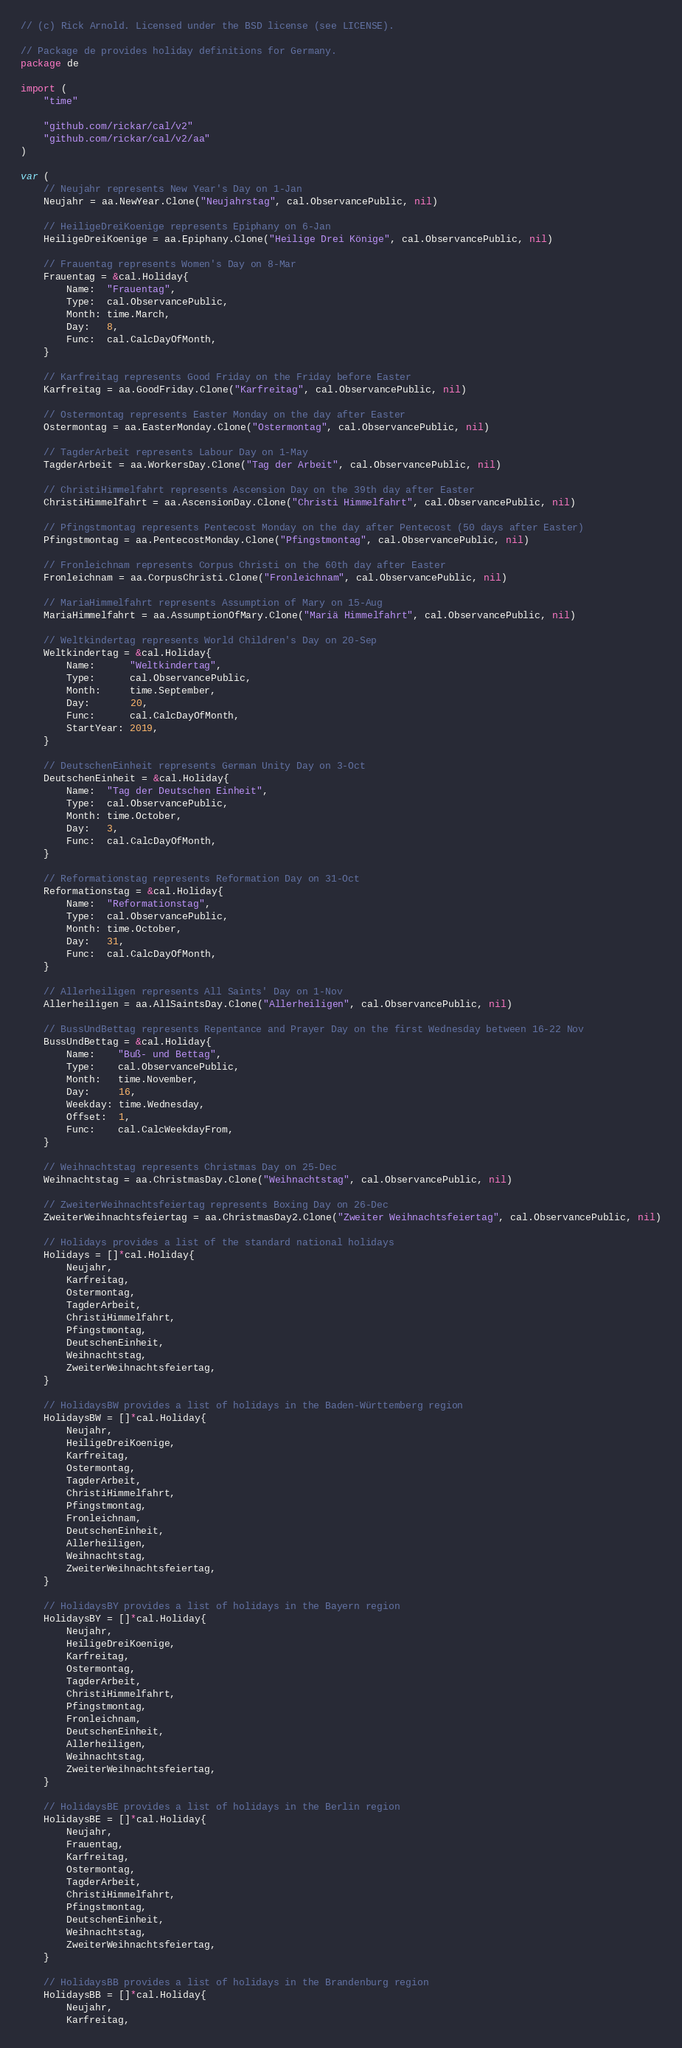<code> <loc_0><loc_0><loc_500><loc_500><_Go_>// (c) Rick Arnold. Licensed under the BSD license (see LICENSE).

// Package de provides holiday definitions for Germany.
package de

import (
	"time"

	"github.com/rickar/cal/v2"
	"github.com/rickar/cal/v2/aa"
)

var (
	// Neujahr represents New Year's Day on 1-Jan
	Neujahr = aa.NewYear.Clone("Neujahrstag", cal.ObservancePublic, nil)

	// HeiligeDreiKoenige represents Epiphany on 6-Jan
	HeiligeDreiKoenige = aa.Epiphany.Clone("Heilige Drei Könige", cal.ObservancePublic, nil)

	// Frauentag represents Women's Day on 8-Mar
	Frauentag = &cal.Holiday{
		Name:  "Frauentag",
		Type:  cal.ObservancePublic,
		Month: time.March,
		Day:   8,
		Func:  cal.CalcDayOfMonth,
	}

	// Karfreitag represents Good Friday on the Friday before Easter
	Karfreitag = aa.GoodFriday.Clone("Karfreitag", cal.ObservancePublic, nil)

	// Ostermontag represents Easter Monday on the day after Easter
	Ostermontag = aa.EasterMonday.Clone("Ostermontag", cal.ObservancePublic, nil)

	// TagderArbeit represents Labour Day on 1-May
	TagderArbeit = aa.WorkersDay.Clone("Tag der Arbeit", cal.ObservancePublic, nil)

	// ChristiHimmelfahrt represents Ascension Day on the 39th day after Easter
	ChristiHimmelfahrt = aa.AscensionDay.Clone("Christi Himmelfahrt", cal.ObservancePublic, nil)

	// Pfingstmontag represents Pentecost Monday on the day after Pentecost (50 days after Easter)
	Pfingstmontag = aa.PentecostMonday.Clone("Pfingstmontag", cal.ObservancePublic, nil)

	// Fronleichnam represents Corpus Christi on the 60th day after Easter
	Fronleichnam = aa.CorpusChristi.Clone("Fronleichnam", cal.ObservancePublic, nil)

	// MariaHimmelfahrt represents Assumption of Mary on 15-Aug
	MariaHimmelfahrt = aa.AssumptionOfMary.Clone("Mariä Himmelfahrt", cal.ObservancePublic, nil)

	// Weltkindertag represents World Children's Day on 20-Sep
	Weltkindertag = &cal.Holiday{
		Name:      "Weltkindertag",
		Type:      cal.ObservancePublic,
		Month:     time.September,
		Day:       20,
		Func:      cal.CalcDayOfMonth,
		StartYear: 2019,
	}

	// DeutschenEinheit represents German Unity Day on 3-Oct
	DeutschenEinheit = &cal.Holiday{
		Name:  "Tag der Deutschen Einheit",
		Type:  cal.ObservancePublic,
		Month: time.October,
		Day:   3,
		Func:  cal.CalcDayOfMonth,
	}

	// Reformationstag represents Reformation Day on 31-Oct
	Reformationstag = &cal.Holiday{
		Name:  "Reformationstag",
		Type:  cal.ObservancePublic,
		Month: time.October,
		Day:   31,
		Func:  cal.CalcDayOfMonth,
	}

	// Allerheiligen represents All Saints' Day on 1-Nov
	Allerheiligen = aa.AllSaintsDay.Clone("Allerheiligen", cal.ObservancePublic, nil)

	// BussUndBettag represents Repentance and Prayer Day on the first Wednesday between 16-22 Nov
	BussUndBettag = &cal.Holiday{
		Name:    "Buß- und Bettag",
		Type:    cal.ObservancePublic,
		Month:   time.November,
		Day:     16,
		Weekday: time.Wednesday,
		Offset:  1,
		Func:    cal.CalcWeekdayFrom,
	}

	// Weihnachtstag represents Christmas Day on 25-Dec
	Weihnachtstag = aa.ChristmasDay.Clone("Weihnachtstag", cal.ObservancePublic, nil)

	// ZweiterWeihnachtsfeiertag represents Boxing Day on 26-Dec
	ZweiterWeihnachtsfeiertag = aa.ChristmasDay2.Clone("Zweiter Weihnachtsfeiertag", cal.ObservancePublic, nil)

	// Holidays provides a list of the standard national holidays
	Holidays = []*cal.Holiday{
		Neujahr,
		Karfreitag,
		Ostermontag,
		TagderArbeit,
		ChristiHimmelfahrt,
		Pfingstmontag,
		DeutschenEinheit,
		Weihnachtstag,
		ZweiterWeihnachtsfeiertag,
	}

	// HolidaysBW provides a list of holidays in the Baden-Württemberg region
	HolidaysBW = []*cal.Holiday{
		Neujahr,
		HeiligeDreiKoenige,
		Karfreitag,
		Ostermontag,
		TagderArbeit,
		ChristiHimmelfahrt,
		Pfingstmontag,
		Fronleichnam,
		DeutschenEinheit,
		Allerheiligen,
		Weihnachtstag,
		ZweiterWeihnachtsfeiertag,
	}

	// HolidaysBY provides a list of holidays in the Bayern region
	HolidaysBY = []*cal.Holiday{
		Neujahr,
		HeiligeDreiKoenige,
		Karfreitag,
		Ostermontag,
		TagderArbeit,
		ChristiHimmelfahrt,
		Pfingstmontag,
		Fronleichnam,
		DeutschenEinheit,
		Allerheiligen,
		Weihnachtstag,
		ZweiterWeihnachtsfeiertag,
	}

	// HolidaysBE provides a list of holidays in the Berlin region
	HolidaysBE = []*cal.Holiday{
		Neujahr,
		Frauentag,
		Karfreitag,
		Ostermontag,
		TagderArbeit,
		ChristiHimmelfahrt,
		Pfingstmontag,
		DeutschenEinheit,
		Weihnachtstag,
		ZweiterWeihnachtsfeiertag,
	}

	// HolidaysBB provides a list of holidays in the Brandenburg region
	HolidaysBB = []*cal.Holiday{
		Neujahr,
		Karfreitag,</code> 